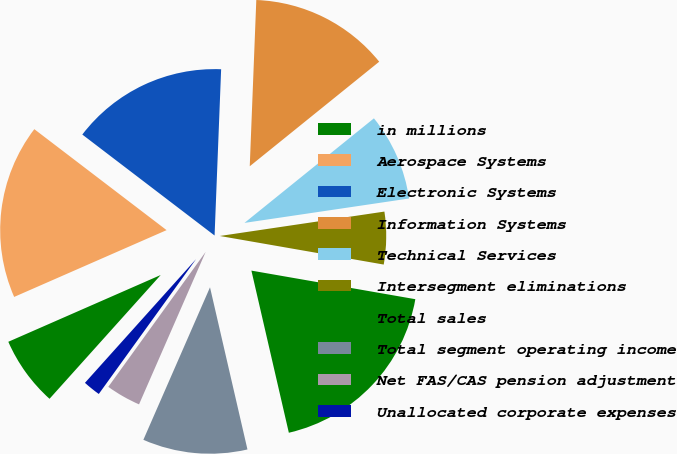Convert chart to OTSL. <chart><loc_0><loc_0><loc_500><loc_500><pie_chart><fcel>in millions<fcel>Aerospace Systems<fcel>Electronic Systems<fcel>Information Systems<fcel>Technical Services<fcel>Intersegment eliminations<fcel>Total sales<fcel>Total segment operating income<fcel>Net FAS/CAS pension adjustment<fcel>Unallocated corporate expenses<nl><fcel>6.78%<fcel>16.95%<fcel>15.25%<fcel>13.56%<fcel>8.47%<fcel>5.09%<fcel>18.64%<fcel>10.17%<fcel>3.39%<fcel>1.7%<nl></chart> 